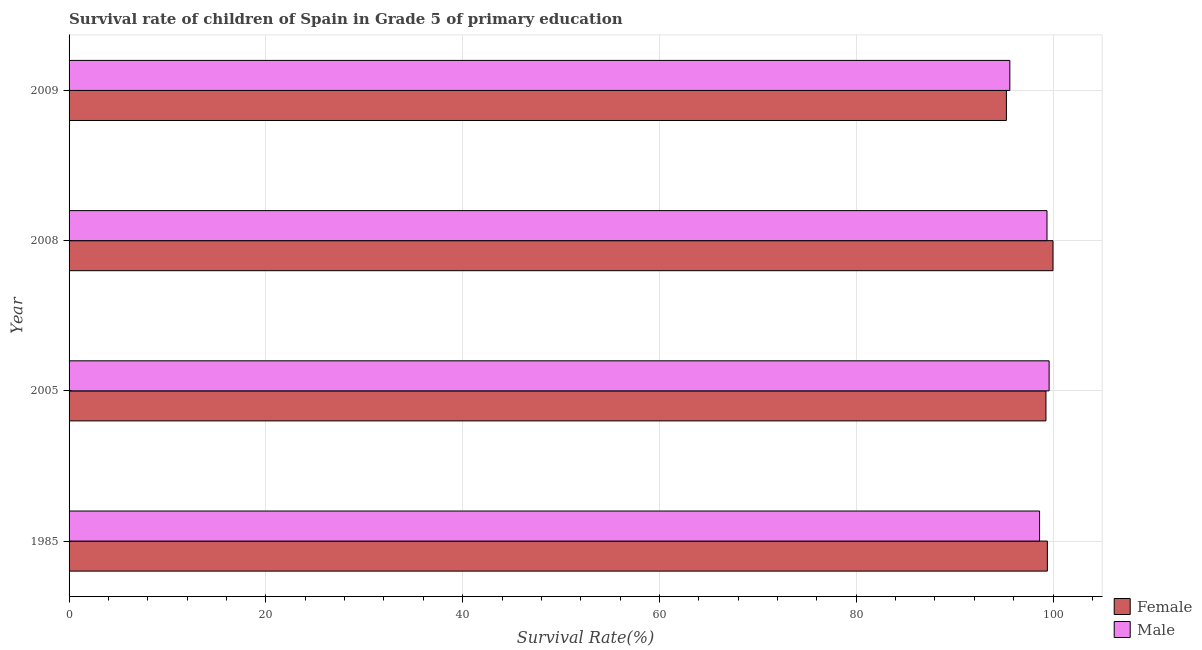How many different coloured bars are there?
Offer a very short reply. 2. How many groups of bars are there?
Give a very brief answer. 4. Are the number of bars on each tick of the Y-axis equal?
Give a very brief answer. Yes. How many bars are there on the 2nd tick from the top?
Your answer should be very brief. 2. How many bars are there on the 3rd tick from the bottom?
Provide a short and direct response. 2. What is the survival rate of female students in primary education in 2005?
Keep it short and to the point. 99.28. Across all years, what is the maximum survival rate of female students in primary education?
Keep it short and to the point. 100. Across all years, what is the minimum survival rate of female students in primary education?
Your answer should be very brief. 95.26. In which year was the survival rate of female students in primary education minimum?
Make the answer very short. 2009. What is the total survival rate of male students in primary education in the graph?
Your answer should be compact. 393.24. What is the difference between the survival rate of male students in primary education in 1985 and that in 2005?
Provide a short and direct response. -0.97. What is the difference between the survival rate of male students in primary education in 1985 and the survival rate of female students in primary education in 2005?
Give a very brief answer. -0.65. What is the average survival rate of female students in primary education per year?
Offer a terse response. 98.49. In the year 2008, what is the difference between the survival rate of female students in primary education and survival rate of male students in primary education?
Your answer should be very brief. 0.61. In how many years, is the survival rate of male students in primary education greater than 48 %?
Ensure brevity in your answer.  4. What is the ratio of the survival rate of male students in primary education in 2005 to that in 2009?
Offer a very short reply. 1.04. What is the difference between the highest and the second highest survival rate of female students in primary education?
Provide a succinct answer. 0.57. What is the difference between the highest and the lowest survival rate of male students in primary education?
Make the answer very short. 3.99. In how many years, is the survival rate of female students in primary education greater than the average survival rate of female students in primary education taken over all years?
Your response must be concise. 3. What does the 1st bar from the top in 2009 represents?
Provide a short and direct response. Male. What does the 1st bar from the bottom in 2008 represents?
Give a very brief answer. Female. How many bars are there?
Give a very brief answer. 8. How many years are there in the graph?
Make the answer very short. 4. What is the difference between two consecutive major ticks on the X-axis?
Provide a short and direct response. 20. Are the values on the major ticks of X-axis written in scientific E-notation?
Offer a very short reply. No. Does the graph contain any zero values?
Ensure brevity in your answer.  No. How are the legend labels stacked?
Provide a succinct answer. Vertical. What is the title of the graph?
Provide a succinct answer. Survival rate of children of Spain in Grade 5 of primary education. What is the label or title of the X-axis?
Your answer should be very brief. Survival Rate(%). What is the label or title of the Y-axis?
Give a very brief answer. Year. What is the Survival Rate(%) of Female in 1985?
Your answer should be compact. 99.42. What is the Survival Rate(%) in Male in 1985?
Your answer should be compact. 98.63. What is the Survival Rate(%) of Female in 2005?
Provide a succinct answer. 99.28. What is the Survival Rate(%) in Male in 2005?
Keep it short and to the point. 99.6. What is the Survival Rate(%) of Female in 2008?
Ensure brevity in your answer.  100. What is the Survival Rate(%) in Male in 2008?
Ensure brevity in your answer.  99.39. What is the Survival Rate(%) in Female in 2009?
Provide a short and direct response. 95.26. What is the Survival Rate(%) of Male in 2009?
Provide a short and direct response. 95.61. Across all years, what is the maximum Survival Rate(%) of Female?
Offer a terse response. 100. Across all years, what is the maximum Survival Rate(%) in Male?
Your response must be concise. 99.6. Across all years, what is the minimum Survival Rate(%) of Female?
Your answer should be compact. 95.26. Across all years, what is the minimum Survival Rate(%) of Male?
Provide a short and direct response. 95.61. What is the total Survival Rate(%) in Female in the graph?
Provide a succinct answer. 393.97. What is the total Survival Rate(%) of Male in the graph?
Your response must be concise. 393.24. What is the difference between the Survival Rate(%) in Female in 1985 and that in 2005?
Keep it short and to the point. 0.14. What is the difference between the Survival Rate(%) of Male in 1985 and that in 2005?
Provide a succinct answer. -0.97. What is the difference between the Survival Rate(%) of Female in 1985 and that in 2008?
Offer a very short reply. -0.57. What is the difference between the Survival Rate(%) of Male in 1985 and that in 2008?
Your response must be concise. -0.76. What is the difference between the Survival Rate(%) of Female in 1985 and that in 2009?
Offer a very short reply. 4.16. What is the difference between the Survival Rate(%) in Male in 1985 and that in 2009?
Offer a terse response. 3.02. What is the difference between the Survival Rate(%) in Female in 2005 and that in 2008?
Ensure brevity in your answer.  -0.71. What is the difference between the Survival Rate(%) of Male in 2005 and that in 2008?
Make the answer very short. 0.22. What is the difference between the Survival Rate(%) in Female in 2005 and that in 2009?
Provide a succinct answer. 4.02. What is the difference between the Survival Rate(%) in Male in 2005 and that in 2009?
Offer a very short reply. 3.99. What is the difference between the Survival Rate(%) in Female in 2008 and that in 2009?
Your answer should be compact. 4.73. What is the difference between the Survival Rate(%) in Male in 2008 and that in 2009?
Ensure brevity in your answer.  3.78. What is the difference between the Survival Rate(%) in Female in 1985 and the Survival Rate(%) in Male in 2005?
Your answer should be very brief. -0.18. What is the difference between the Survival Rate(%) in Female in 1985 and the Survival Rate(%) in Male in 2008?
Provide a succinct answer. 0.04. What is the difference between the Survival Rate(%) of Female in 1985 and the Survival Rate(%) of Male in 2009?
Make the answer very short. 3.81. What is the difference between the Survival Rate(%) in Female in 2005 and the Survival Rate(%) in Male in 2008?
Make the answer very short. -0.1. What is the difference between the Survival Rate(%) in Female in 2005 and the Survival Rate(%) in Male in 2009?
Offer a terse response. 3.67. What is the difference between the Survival Rate(%) of Female in 2008 and the Survival Rate(%) of Male in 2009?
Ensure brevity in your answer.  4.39. What is the average Survival Rate(%) of Female per year?
Your answer should be very brief. 98.49. What is the average Survival Rate(%) of Male per year?
Offer a very short reply. 98.31. In the year 1985, what is the difference between the Survival Rate(%) of Female and Survival Rate(%) of Male?
Your answer should be compact. 0.79. In the year 2005, what is the difference between the Survival Rate(%) in Female and Survival Rate(%) in Male?
Provide a short and direct response. -0.32. In the year 2008, what is the difference between the Survival Rate(%) in Female and Survival Rate(%) in Male?
Give a very brief answer. 0.61. In the year 2009, what is the difference between the Survival Rate(%) in Female and Survival Rate(%) in Male?
Provide a succinct answer. -0.35. What is the ratio of the Survival Rate(%) in Female in 1985 to that in 2005?
Offer a terse response. 1. What is the ratio of the Survival Rate(%) in Male in 1985 to that in 2005?
Give a very brief answer. 0.99. What is the ratio of the Survival Rate(%) in Female in 1985 to that in 2008?
Your response must be concise. 0.99. What is the ratio of the Survival Rate(%) in Male in 1985 to that in 2008?
Provide a short and direct response. 0.99. What is the ratio of the Survival Rate(%) in Female in 1985 to that in 2009?
Your response must be concise. 1.04. What is the ratio of the Survival Rate(%) of Male in 1985 to that in 2009?
Make the answer very short. 1.03. What is the ratio of the Survival Rate(%) in Male in 2005 to that in 2008?
Offer a very short reply. 1. What is the ratio of the Survival Rate(%) in Female in 2005 to that in 2009?
Make the answer very short. 1.04. What is the ratio of the Survival Rate(%) of Male in 2005 to that in 2009?
Your response must be concise. 1.04. What is the ratio of the Survival Rate(%) in Female in 2008 to that in 2009?
Make the answer very short. 1.05. What is the ratio of the Survival Rate(%) in Male in 2008 to that in 2009?
Your answer should be compact. 1.04. What is the difference between the highest and the second highest Survival Rate(%) in Female?
Make the answer very short. 0.57. What is the difference between the highest and the second highest Survival Rate(%) in Male?
Provide a succinct answer. 0.22. What is the difference between the highest and the lowest Survival Rate(%) in Female?
Your answer should be very brief. 4.73. What is the difference between the highest and the lowest Survival Rate(%) of Male?
Provide a short and direct response. 3.99. 